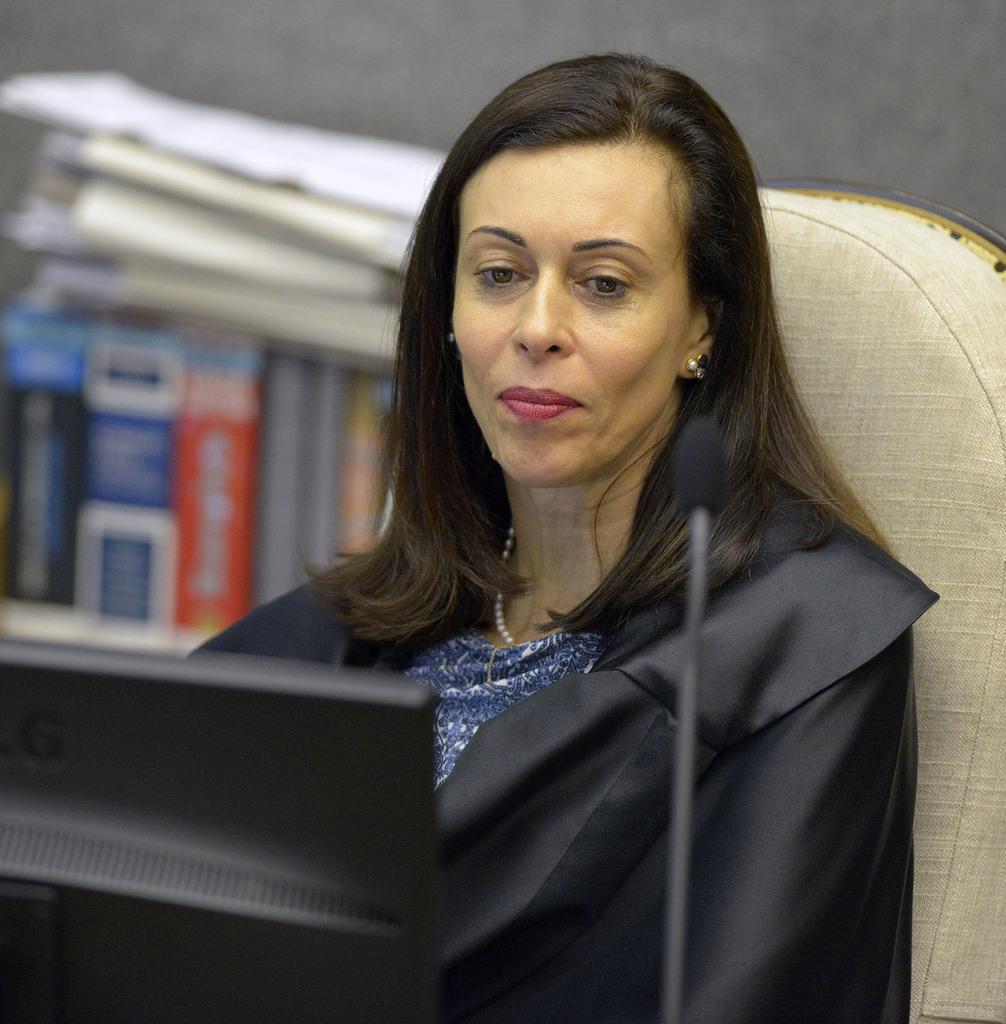In one or two sentences, can you explain what this image depicts? In this image, we can see a lady sitting on the chair and wearing a coat and we can see a monitor and a mic. In the background, there are books and papers. 